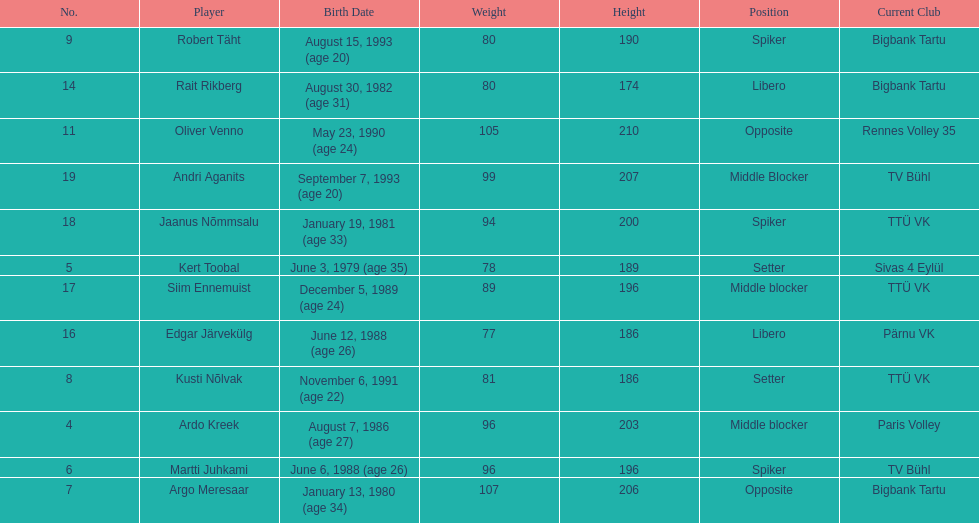Kert toobal is the oldest who is the next oldest player listed? Argo Meresaar. 